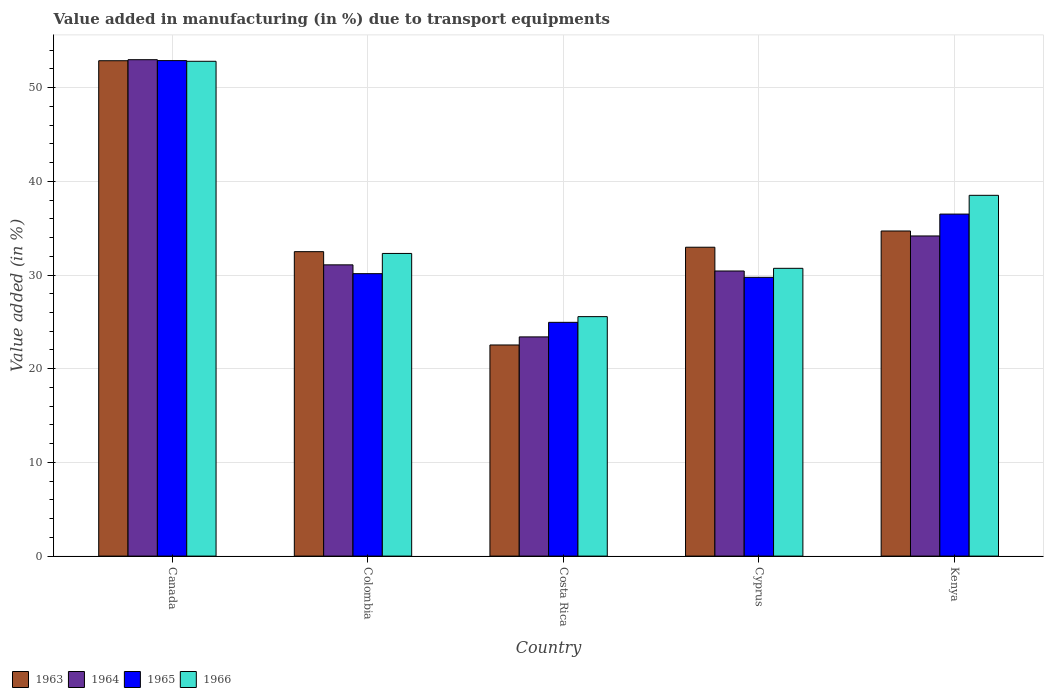How many different coloured bars are there?
Give a very brief answer. 4. How many bars are there on the 5th tick from the left?
Give a very brief answer. 4. How many bars are there on the 4th tick from the right?
Offer a very short reply. 4. What is the label of the 3rd group of bars from the left?
Provide a succinct answer. Costa Rica. What is the percentage of value added in manufacturing due to transport equipments in 1964 in Kenya?
Provide a succinct answer. 34.17. Across all countries, what is the maximum percentage of value added in manufacturing due to transport equipments in 1964?
Make the answer very short. 52.98. Across all countries, what is the minimum percentage of value added in manufacturing due to transport equipments in 1963?
Keep it short and to the point. 22.53. What is the total percentage of value added in manufacturing due to transport equipments in 1966 in the graph?
Give a very brief answer. 179.9. What is the difference between the percentage of value added in manufacturing due to transport equipments in 1964 in Canada and that in Kenya?
Your answer should be compact. 18.81. What is the difference between the percentage of value added in manufacturing due to transport equipments in 1964 in Kenya and the percentage of value added in manufacturing due to transport equipments in 1966 in Colombia?
Provide a short and direct response. 1.87. What is the average percentage of value added in manufacturing due to transport equipments in 1963 per country?
Make the answer very short. 35.11. What is the difference between the percentage of value added in manufacturing due to transport equipments of/in 1965 and percentage of value added in manufacturing due to transport equipments of/in 1964 in Colombia?
Give a very brief answer. -0.94. In how many countries, is the percentage of value added in manufacturing due to transport equipments in 1966 greater than 12 %?
Ensure brevity in your answer.  5. What is the ratio of the percentage of value added in manufacturing due to transport equipments in 1966 in Canada to that in Kenya?
Provide a short and direct response. 1.37. Is the percentage of value added in manufacturing due to transport equipments in 1966 in Canada less than that in Cyprus?
Your response must be concise. No. Is the difference between the percentage of value added in manufacturing due to transport equipments in 1965 in Cyprus and Kenya greater than the difference between the percentage of value added in manufacturing due to transport equipments in 1964 in Cyprus and Kenya?
Your answer should be very brief. No. What is the difference between the highest and the second highest percentage of value added in manufacturing due to transport equipments in 1963?
Offer a terse response. -1.73. What is the difference between the highest and the lowest percentage of value added in manufacturing due to transport equipments in 1965?
Your answer should be very brief. 27.93. Is it the case that in every country, the sum of the percentage of value added in manufacturing due to transport equipments in 1964 and percentage of value added in manufacturing due to transport equipments in 1966 is greater than the sum of percentage of value added in manufacturing due to transport equipments in 1963 and percentage of value added in manufacturing due to transport equipments in 1965?
Provide a short and direct response. No. What does the 3rd bar from the left in Kenya represents?
Your answer should be compact. 1965. What does the 4th bar from the right in Colombia represents?
Make the answer very short. 1963. How many bars are there?
Your response must be concise. 20. What is the difference between two consecutive major ticks on the Y-axis?
Your answer should be very brief. 10. Does the graph contain any zero values?
Provide a succinct answer. No. Does the graph contain grids?
Provide a succinct answer. Yes. What is the title of the graph?
Offer a terse response. Value added in manufacturing (in %) due to transport equipments. What is the label or title of the X-axis?
Your answer should be very brief. Country. What is the label or title of the Y-axis?
Ensure brevity in your answer.  Value added (in %). What is the Value added (in %) in 1963 in Canada?
Keep it short and to the point. 52.87. What is the Value added (in %) of 1964 in Canada?
Your answer should be compact. 52.98. What is the Value added (in %) of 1965 in Canada?
Make the answer very short. 52.89. What is the Value added (in %) of 1966 in Canada?
Offer a very short reply. 52.81. What is the Value added (in %) in 1963 in Colombia?
Provide a succinct answer. 32.49. What is the Value added (in %) of 1964 in Colombia?
Offer a terse response. 31.09. What is the Value added (in %) of 1965 in Colombia?
Keep it short and to the point. 30.15. What is the Value added (in %) of 1966 in Colombia?
Provide a succinct answer. 32.3. What is the Value added (in %) in 1963 in Costa Rica?
Offer a very short reply. 22.53. What is the Value added (in %) of 1964 in Costa Rica?
Your answer should be very brief. 23.4. What is the Value added (in %) of 1965 in Costa Rica?
Your answer should be compact. 24.95. What is the Value added (in %) of 1966 in Costa Rica?
Your answer should be compact. 25.56. What is the Value added (in %) of 1963 in Cyprus?
Provide a short and direct response. 32.97. What is the Value added (in %) in 1964 in Cyprus?
Your answer should be compact. 30.43. What is the Value added (in %) of 1965 in Cyprus?
Make the answer very short. 29.75. What is the Value added (in %) in 1966 in Cyprus?
Your answer should be compact. 30.72. What is the Value added (in %) of 1963 in Kenya?
Make the answer very short. 34.7. What is the Value added (in %) in 1964 in Kenya?
Make the answer very short. 34.17. What is the Value added (in %) in 1965 in Kenya?
Your response must be concise. 36.5. What is the Value added (in %) of 1966 in Kenya?
Give a very brief answer. 38.51. Across all countries, what is the maximum Value added (in %) in 1963?
Keep it short and to the point. 52.87. Across all countries, what is the maximum Value added (in %) of 1964?
Offer a very short reply. 52.98. Across all countries, what is the maximum Value added (in %) in 1965?
Your response must be concise. 52.89. Across all countries, what is the maximum Value added (in %) of 1966?
Provide a short and direct response. 52.81. Across all countries, what is the minimum Value added (in %) in 1963?
Your answer should be compact. 22.53. Across all countries, what is the minimum Value added (in %) of 1964?
Offer a very short reply. 23.4. Across all countries, what is the minimum Value added (in %) of 1965?
Your answer should be very brief. 24.95. Across all countries, what is the minimum Value added (in %) of 1966?
Keep it short and to the point. 25.56. What is the total Value added (in %) of 1963 in the graph?
Keep it short and to the point. 175.57. What is the total Value added (in %) of 1964 in the graph?
Offer a terse response. 172.06. What is the total Value added (in %) of 1965 in the graph?
Provide a succinct answer. 174.24. What is the total Value added (in %) in 1966 in the graph?
Your response must be concise. 179.9. What is the difference between the Value added (in %) of 1963 in Canada and that in Colombia?
Make the answer very short. 20.38. What is the difference between the Value added (in %) in 1964 in Canada and that in Colombia?
Give a very brief answer. 21.9. What is the difference between the Value added (in %) of 1965 in Canada and that in Colombia?
Make the answer very short. 22.74. What is the difference between the Value added (in %) of 1966 in Canada and that in Colombia?
Offer a terse response. 20.51. What is the difference between the Value added (in %) of 1963 in Canada and that in Costa Rica?
Provide a succinct answer. 30.34. What is the difference between the Value added (in %) in 1964 in Canada and that in Costa Rica?
Offer a very short reply. 29.59. What is the difference between the Value added (in %) of 1965 in Canada and that in Costa Rica?
Ensure brevity in your answer.  27.93. What is the difference between the Value added (in %) of 1966 in Canada and that in Costa Rica?
Provide a short and direct response. 27.25. What is the difference between the Value added (in %) in 1963 in Canada and that in Cyprus?
Your response must be concise. 19.91. What is the difference between the Value added (in %) in 1964 in Canada and that in Cyprus?
Your answer should be very brief. 22.55. What is the difference between the Value added (in %) in 1965 in Canada and that in Cyprus?
Your answer should be compact. 23.13. What is the difference between the Value added (in %) of 1966 in Canada and that in Cyprus?
Provide a short and direct response. 22.1. What is the difference between the Value added (in %) of 1963 in Canada and that in Kenya?
Offer a very short reply. 18.17. What is the difference between the Value added (in %) in 1964 in Canada and that in Kenya?
Keep it short and to the point. 18.81. What is the difference between the Value added (in %) of 1965 in Canada and that in Kenya?
Make the answer very short. 16.38. What is the difference between the Value added (in %) of 1966 in Canada and that in Kenya?
Offer a terse response. 14.3. What is the difference between the Value added (in %) of 1963 in Colombia and that in Costa Rica?
Offer a terse response. 9.96. What is the difference between the Value added (in %) of 1964 in Colombia and that in Costa Rica?
Provide a succinct answer. 7.69. What is the difference between the Value added (in %) of 1965 in Colombia and that in Costa Rica?
Keep it short and to the point. 5.2. What is the difference between the Value added (in %) of 1966 in Colombia and that in Costa Rica?
Keep it short and to the point. 6.74. What is the difference between the Value added (in %) in 1963 in Colombia and that in Cyprus?
Offer a very short reply. -0.47. What is the difference between the Value added (in %) of 1964 in Colombia and that in Cyprus?
Give a very brief answer. 0.66. What is the difference between the Value added (in %) of 1965 in Colombia and that in Cyprus?
Make the answer very short. 0.39. What is the difference between the Value added (in %) of 1966 in Colombia and that in Cyprus?
Your response must be concise. 1.59. What is the difference between the Value added (in %) of 1963 in Colombia and that in Kenya?
Your response must be concise. -2.21. What is the difference between the Value added (in %) of 1964 in Colombia and that in Kenya?
Provide a succinct answer. -3.08. What is the difference between the Value added (in %) in 1965 in Colombia and that in Kenya?
Provide a succinct answer. -6.36. What is the difference between the Value added (in %) in 1966 in Colombia and that in Kenya?
Provide a short and direct response. -6.2. What is the difference between the Value added (in %) in 1963 in Costa Rica and that in Cyprus?
Your answer should be very brief. -10.43. What is the difference between the Value added (in %) in 1964 in Costa Rica and that in Cyprus?
Keep it short and to the point. -7.03. What is the difference between the Value added (in %) in 1965 in Costa Rica and that in Cyprus?
Offer a very short reply. -4.8. What is the difference between the Value added (in %) in 1966 in Costa Rica and that in Cyprus?
Give a very brief answer. -5.16. What is the difference between the Value added (in %) of 1963 in Costa Rica and that in Kenya?
Keep it short and to the point. -12.17. What is the difference between the Value added (in %) in 1964 in Costa Rica and that in Kenya?
Your answer should be compact. -10.77. What is the difference between the Value added (in %) in 1965 in Costa Rica and that in Kenya?
Give a very brief answer. -11.55. What is the difference between the Value added (in %) of 1966 in Costa Rica and that in Kenya?
Provide a short and direct response. -12.95. What is the difference between the Value added (in %) in 1963 in Cyprus and that in Kenya?
Offer a very short reply. -1.73. What is the difference between the Value added (in %) of 1964 in Cyprus and that in Kenya?
Make the answer very short. -3.74. What is the difference between the Value added (in %) in 1965 in Cyprus and that in Kenya?
Give a very brief answer. -6.75. What is the difference between the Value added (in %) in 1966 in Cyprus and that in Kenya?
Offer a very short reply. -7.79. What is the difference between the Value added (in %) of 1963 in Canada and the Value added (in %) of 1964 in Colombia?
Provide a succinct answer. 21.79. What is the difference between the Value added (in %) of 1963 in Canada and the Value added (in %) of 1965 in Colombia?
Offer a terse response. 22.73. What is the difference between the Value added (in %) in 1963 in Canada and the Value added (in %) in 1966 in Colombia?
Your response must be concise. 20.57. What is the difference between the Value added (in %) in 1964 in Canada and the Value added (in %) in 1965 in Colombia?
Offer a very short reply. 22.84. What is the difference between the Value added (in %) of 1964 in Canada and the Value added (in %) of 1966 in Colombia?
Offer a terse response. 20.68. What is the difference between the Value added (in %) of 1965 in Canada and the Value added (in %) of 1966 in Colombia?
Offer a very short reply. 20.58. What is the difference between the Value added (in %) in 1963 in Canada and the Value added (in %) in 1964 in Costa Rica?
Your response must be concise. 29.48. What is the difference between the Value added (in %) in 1963 in Canada and the Value added (in %) in 1965 in Costa Rica?
Keep it short and to the point. 27.92. What is the difference between the Value added (in %) of 1963 in Canada and the Value added (in %) of 1966 in Costa Rica?
Provide a short and direct response. 27.31. What is the difference between the Value added (in %) of 1964 in Canada and the Value added (in %) of 1965 in Costa Rica?
Ensure brevity in your answer.  28.03. What is the difference between the Value added (in %) of 1964 in Canada and the Value added (in %) of 1966 in Costa Rica?
Give a very brief answer. 27.42. What is the difference between the Value added (in %) in 1965 in Canada and the Value added (in %) in 1966 in Costa Rica?
Make the answer very short. 27.33. What is the difference between the Value added (in %) in 1963 in Canada and the Value added (in %) in 1964 in Cyprus?
Provide a succinct answer. 22.44. What is the difference between the Value added (in %) of 1963 in Canada and the Value added (in %) of 1965 in Cyprus?
Keep it short and to the point. 23.12. What is the difference between the Value added (in %) of 1963 in Canada and the Value added (in %) of 1966 in Cyprus?
Offer a terse response. 22.16. What is the difference between the Value added (in %) of 1964 in Canada and the Value added (in %) of 1965 in Cyprus?
Your answer should be very brief. 23.23. What is the difference between the Value added (in %) in 1964 in Canada and the Value added (in %) in 1966 in Cyprus?
Your answer should be very brief. 22.27. What is the difference between the Value added (in %) in 1965 in Canada and the Value added (in %) in 1966 in Cyprus?
Offer a terse response. 22.17. What is the difference between the Value added (in %) in 1963 in Canada and the Value added (in %) in 1964 in Kenya?
Make the answer very short. 18.7. What is the difference between the Value added (in %) of 1963 in Canada and the Value added (in %) of 1965 in Kenya?
Keep it short and to the point. 16.37. What is the difference between the Value added (in %) of 1963 in Canada and the Value added (in %) of 1966 in Kenya?
Provide a succinct answer. 14.37. What is the difference between the Value added (in %) of 1964 in Canada and the Value added (in %) of 1965 in Kenya?
Keep it short and to the point. 16.48. What is the difference between the Value added (in %) of 1964 in Canada and the Value added (in %) of 1966 in Kenya?
Give a very brief answer. 14.47. What is the difference between the Value added (in %) in 1965 in Canada and the Value added (in %) in 1966 in Kenya?
Give a very brief answer. 14.38. What is the difference between the Value added (in %) in 1963 in Colombia and the Value added (in %) in 1964 in Costa Rica?
Ensure brevity in your answer.  9.1. What is the difference between the Value added (in %) in 1963 in Colombia and the Value added (in %) in 1965 in Costa Rica?
Your answer should be compact. 7.54. What is the difference between the Value added (in %) in 1963 in Colombia and the Value added (in %) in 1966 in Costa Rica?
Make the answer very short. 6.93. What is the difference between the Value added (in %) of 1964 in Colombia and the Value added (in %) of 1965 in Costa Rica?
Keep it short and to the point. 6.14. What is the difference between the Value added (in %) of 1964 in Colombia and the Value added (in %) of 1966 in Costa Rica?
Your response must be concise. 5.53. What is the difference between the Value added (in %) in 1965 in Colombia and the Value added (in %) in 1966 in Costa Rica?
Your answer should be compact. 4.59. What is the difference between the Value added (in %) of 1963 in Colombia and the Value added (in %) of 1964 in Cyprus?
Offer a very short reply. 2.06. What is the difference between the Value added (in %) of 1963 in Colombia and the Value added (in %) of 1965 in Cyprus?
Make the answer very short. 2.74. What is the difference between the Value added (in %) in 1963 in Colombia and the Value added (in %) in 1966 in Cyprus?
Make the answer very short. 1.78. What is the difference between the Value added (in %) in 1964 in Colombia and the Value added (in %) in 1965 in Cyprus?
Keep it short and to the point. 1.33. What is the difference between the Value added (in %) of 1964 in Colombia and the Value added (in %) of 1966 in Cyprus?
Provide a succinct answer. 0.37. What is the difference between the Value added (in %) of 1965 in Colombia and the Value added (in %) of 1966 in Cyprus?
Your answer should be very brief. -0.57. What is the difference between the Value added (in %) of 1963 in Colombia and the Value added (in %) of 1964 in Kenya?
Offer a terse response. -1.68. What is the difference between the Value added (in %) of 1963 in Colombia and the Value added (in %) of 1965 in Kenya?
Make the answer very short. -4.01. What is the difference between the Value added (in %) in 1963 in Colombia and the Value added (in %) in 1966 in Kenya?
Your answer should be very brief. -6.01. What is the difference between the Value added (in %) of 1964 in Colombia and the Value added (in %) of 1965 in Kenya?
Your response must be concise. -5.42. What is the difference between the Value added (in %) of 1964 in Colombia and the Value added (in %) of 1966 in Kenya?
Ensure brevity in your answer.  -7.42. What is the difference between the Value added (in %) of 1965 in Colombia and the Value added (in %) of 1966 in Kenya?
Offer a very short reply. -8.36. What is the difference between the Value added (in %) of 1963 in Costa Rica and the Value added (in %) of 1964 in Cyprus?
Keep it short and to the point. -7.9. What is the difference between the Value added (in %) of 1963 in Costa Rica and the Value added (in %) of 1965 in Cyprus?
Ensure brevity in your answer.  -7.22. What is the difference between the Value added (in %) of 1963 in Costa Rica and the Value added (in %) of 1966 in Cyprus?
Keep it short and to the point. -8.18. What is the difference between the Value added (in %) of 1964 in Costa Rica and the Value added (in %) of 1965 in Cyprus?
Provide a short and direct response. -6.36. What is the difference between the Value added (in %) in 1964 in Costa Rica and the Value added (in %) in 1966 in Cyprus?
Your response must be concise. -7.32. What is the difference between the Value added (in %) in 1965 in Costa Rica and the Value added (in %) in 1966 in Cyprus?
Ensure brevity in your answer.  -5.77. What is the difference between the Value added (in %) in 1963 in Costa Rica and the Value added (in %) in 1964 in Kenya?
Provide a short and direct response. -11.64. What is the difference between the Value added (in %) of 1963 in Costa Rica and the Value added (in %) of 1965 in Kenya?
Your answer should be very brief. -13.97. What is the difference between the Value added (in %) of 1963 in Costa Rica and the Value added (in %) of 1966 in Kenya?
Keep it short and to the point. -15.97. What is the difference between the Value added (in %) of 1964 in Costa Rica and the Value added (in %) of 1965 in Kenya?
Your answer should be compact. -13.11. What is the difference between the Value added (in %) of 1964 in Costa Rica and the Value added (in %) of 1966 in Kenya?
Your answer should be very brief. -15.11. What is the difference between the Value added (in %) in 1965 in Costa Rica and the Value added (in %) in 1966 in Kenya?
Your answer should be compact. -13.56. What is the difference between the Value added (in %) in 1963 in Cyprus and the Value added (in %) in 1964 in Kenya?
Offer a terse response. -1.2. What is the difference between the Value added (in %) of 1963 in Cyprus and the Value added (in %) of 1965 in Kenya?
Your answer should be compact. -3.54. What is the difference between the Value added (in %) of 1963 in Cyprus and the Value added (in %) of 1966 in Kenya?
Keep it short and to the point. -5.54. What is the difference between the Value added (in %) of 1964 in Cyprus and the Value added (in %) of 1965 in Kenya?
Your answer should be very brief. -6.07. What is the difference between the Value added (in %) in 1964 in Cyprus and the Value added (in %) in 1966 in Kenya?
Make the answer very short. -8.08. What is the difference between the Value added (in %) of 1965 in Cyprus and the Value added (in %) of 1966 in Kenya?
Ensure brevity in your answer.  -8.75. What is the average Value added (in %) of 1963 per country?
Provide a short and direct response. 35.11. What is the average Value added (in %) in 1964 per country?
Make the answer very short. 34.41. What is the average Value added (in %) in 1965 per country?
Your response must be concise. 34.85. What is the average Value added (in %) of 1966 per country?
Make the answer very short. 35.98. What is the difference between the Value added (in %) of 1963 and Value added (in %) of 1964 in Canada?
Give a very brief answer. -0.11. What is the difference between the Value added (in %) of 1963 and Value added (in %) of 1965 in Canada?
Give a very brief answer. -0.01. What is the difference between the Value added (in %) of 1963 and Value added (in %) of 1966 in Canada?
Give a very brief answer. 0.06. What is the difference between the Value added (in %) in 1964 and Value added (in %) in 1965 in Canada?
Ensure brevity in your answer.  0.1. What is the difference between the Value added (in %) in 1964 and Value added (in %) in 1966 in Canada?
Your response must be concise. 0.17. What is the difference between the Value added (in %) in 1965 and Value added (in %) in 1966 in Canada?
Make the answer very short. 0.07. What is the difference between the Value added (in %) in 1963 and Value added (in %) in 1964 in Colombia?
Provide a short and direct response. 1.41. What is the difference between the Value added (in %) in 1963 and Value added (in %) in 1965 in Colombia?
Provide a short and direct response. 2.35. What is the difference between the Value added (in %) of 1963 and Value added (in %) of 1966 in Colombia?
Offer a terse response. 0.19. What is the difference between the Value added (in %) in 1964 and Value added (in %) in 1965 in Colombia?
Provide a succinct answer. 0.94. What is the difference between the Value added (in %) of 1964 and Value added (in %) of 1966 in Colombia?
Your answer should be compact. -1.22. What is the difference between the Value added (in %) of 1965 and Value added (in %) of 1966 in Colombia?
Ensure brevity in your answer.  -2.16. What is the difference between the Value added (in %) of 1963 and Value added (in %) of 1964 in Costa Rica?
Provide a short and direct response. -0.86. What is the difference between the Value added (in %) of 1963 and Value added (in %) of 1965 in Costa Rica?
Offer a terse response. -2.42. What is the difference between the Value added (in %) in 1963 and Value added (in %) in 1966 in Costa Rica?
Your response must be concise. -3.03. What is the difference between the Value added (in %) in 1964 and Value added (in %) in 1965 in Costa Rica?
Offer a very short reply. -1.55. What is the difference between the Value added (in %) in 1964 and Value added (in %) in 1966 in Costa Rica?
Your response must be concise. -2.16. What is the difference between the Value added (in %) of 1965 and Value added (in %) of 1966 in Costa Rica?
Provide a short and direct response. -0.61. What is the difference between the Value added (in %) in 1963 and Value added (in %) in 1964 in Cyprus?
Make the answer very short. 2.54. What is the difference between the Value added (in %) in 1963 and Value added (in %) in 1965 in Cyprus?
Ensure brevity in your answer.  3.21. What is the difference between the Value added (in %) of 1963 and Value added (in %) of 1966 in Cyprus?
Keep it short and to the point. 2.25. What is the difference between the Value added (in %) in 1964 and Value added (in %) in 1965 in Cyprus?
Your answer should be compact. 0.68. What is the difference between the Value added (in %) of 1964 and Value added (in %) of 1966 in Cyprus?
Your response must be concise. -0.29. What is the difference between the Value added (in %) of 1965 and Value added (in %) of 1966 in Cyprus?
Provide a short and direct response. -0.96. What is the difference between the Value added (in %) of 1963 and Value added (in %) of 1964 in Kenya?
Ensure brevity in your answer.  0.53. What is the difference between the Value added (in %) in 1963 and Value added (in %) in 1965 in Kenya?
Make the answer very short. -1.8. What is the difference between the Value added (in %) of 1963 and Value added (in %) of 1966 in Kenya?
Offer a very short reply. -3.81. What is the difference between the Value added (in %) in 1964 and Value added (in %) in 1965 in Kenya?
Make the answer very short. -2.33. What is the difference between the Value added (in %) in 1964 and Value added (in %) in 1966 in Kenya?
Ensure brevity in your answer.  -4.34. What is the difference between the Value added (in %) of 1965 and Value added (in %) of 1966 in Kenya?
Your answer should be compact. -2. What is the ratio of the Value added (in %) in 1963 in Canada to that in Colombia?
Provide a short and direct response. 1.63. What is the ratio of the Value added (in %) of 1964 in Canada to that in Colombia?
Provide a succinct answer. 1.7. What is the ratio of the Value added (in %) in 1965 in Canada to that in Colombia?
Your answer should be compact. 1.75. What is the ratio of the Value added (in %) in 1966 in Canada to that in Colombia?
Your answer should be very brief. 1.63. What is the ratio of the Value added (in %) of 1963 in Canada to that in Costa Rica?
Ensure brevity in your answer.  2.35. What is the ratio of the Value added (in %) of 1964 in Canada to that in Costa Rica?
Your answer should be compact. 2.26. What is the ratio of the Value added (in %) in 1965 in Canada to that in Costa Rica?
Provide a short and direct response. 2.12. What is the ratio of the Value added (in %) of 1966 in Canada to that in Costa Rica?
Your answer should be very brief. 2.07. What is the ratio of the Value added (in %) in 1963 in Canada to that in Cyprus?
Offer a very short reply. 1.6. What is the ratio of the Value added (in %) of 1964 in Canada to that in Cyprus?
Offer a terse response. 1.74. What is the ratio of the Value added (in %) in 1965 in Canada to that in Cyprus?
Your response must be concise. 1.78. What is the ratio of the Value added (in %) in 1966 in Canada to that in Cyprus?
Offer a terse response. 1.72. What is the ratio of the Value added (in %) of 1963 in Canada to that in Kenya?
Make the answer very short. 1.52. What is the ratio of the Value added (in %) in 1964 in Canada to that in Kenya?
Provide a succinct answer. 1.55. What is the ratio of the Value added (in %) in 1965 in Canada to that in Kenya?
Keep it short and to the point. 1.45. What is the ratio of the Value added (in %) in 1966 in Canada to that in Kenya?
Provide a succinct answer. 1.37. What is the ratio of the Value added (in %) in 1963 in Colombia to that in Costa Rica?
Offer a very short reply. 1.44. What is the ratio of the Value added (in %) in 1964 in Colombia to that in Costa Rica?
Offer a terse response. 1.33. What is the ratio of the Value added (in %) in 1965 in Colombia to that in Costa Rica?
Give a very brief answer. 1.21. What is the ratio of the Value added (in %) of 1966 in Colombia to that in Costa Rica?
Your answer should be compact. 1.26. What is the ratio of the Value added (in %) of 1963 in Colombia to that in Cyprus?
Ensure brevity in your answer.  0.99. What is the ratio of the Value added (in %) of 1964 in Colombia to that in Cyprus?
Provide a short and direct response. 1.02. What is the ratio of the Value added (in %) in 1965 in Colombia to that in Cyprus?
Offer a terse response. 1.01. What is the ratio of the Value added (in %) in 1966 in Colombia to that in Cyprus?
Make the answer very short. 1.05. What is the ratio of the Value added (in %) in 1963 in Colombia to that in Kenya?
Give a very brief answer. 0.94. What is the ratio of the Value added (in %) of 1964 in Colombia to that in Kenya?
Offer a terse response. 0.91. What is the ratio of the Value added (in %) of 1965 in Colombia to that in Kenya?
Offer a very short reply. 0.83. What is the ratio of the Value added (in %) in 1966 in Colombia to that in Kenya?
Your response must be concise. 0.84. What is the ratio of the Value added (in %) of 1963 in Costa Rica to that in Cyprus?
Give a very brief answer. 0.68. What is the ratio of the Value added (in %) of 1964 in Costa Rica to that in Cyprus?
Make the answer very short. 0.77. What is the ratio of the Value added (in %) of 1965 in Costa Rica to that in Cyprus?
Provide a succinct answer. 0.84. What is the ratio of the Value added (in %) in 1966 in Costa Rica to that in Cyprus?
Ensure brevity in your answer.  0.83. What is the ratio of the Value added (in %) in 1963 in Costa Rica to that in Kenya?
Ensure brevity in your answer.  0.65. What is the ratio of the Value added (in %) in 1964 in Costa Rica to that in Kenya?
Provide a short and direct response. 0.68. What is the ratio of the Value added (in %) in 1965 in Costa Rica to that in Kenya?
Ensure brevity in your answer.  0.68. What is the ratio of the Value added (in %) in 1966 in Costa Rica to that in Kenya?
Ensure brevity in your answer.  0.66. What is the ratio of the Value added (in %) in 1963 in Cyprus to that in Kenya?
Make the answer very short. 0.95. What is the ratio of the Value added (in %) of 1964 in Cyprus to that in Kenya?
Provide a succinct answer. 0.89. What is the ratio of the Value added (in %) of 1965 in Cyprus to that in Kenya?
Ensure brevity in your answer.  0.82. What is the ratio of the Value added (in %) of 1966 in Cyprus to that in Kenya?
Ensure brevity in your answer.  0.8. What is the difference between the highest and the second highest Value added (in %) in 1963?
Make the answer very short. 18.17. What is the difference between the highest and the second highest Value added (in %) in 1964?
Keep it short and to the point. 18.81. What is the difference between the highest and the second highest Value added (in %) of 1965?
Provide a succinct answer. 16.38. What is the difference between the highest and the second highest Value added (in %) in 1966?
Provide a succinct answer. 14.3. What is the difference between the highest and the lowest Value added (in %) in 1963?
Make the answer very short. 30.34. What is the difference between the highest and the lowest Value added (in %) of 1964?
Provide a short and direct response. 29.59. What is the difference between the highest and the lowest Value added (in %) in 1965?
Offer a very short reply. 27.93. What is the difference between the highest and the lowest Value added (in %) in 1966?
Your answer should be compact. 27.25. 